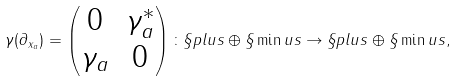<formula> <loc_0><loc_0><loc_500><loc_500>\gamma ( \partial _ { x _ { a } } ) = \begin{pmatrix} 0 & \gamma _ { a } ^ { \ast } \\ \gamma _ { a } & 0 \end{pmatrix} \colon \S p l u s \oplus \S \min u s \rightarrow \S p l u s \oplus \S \min u s ,</formula> 